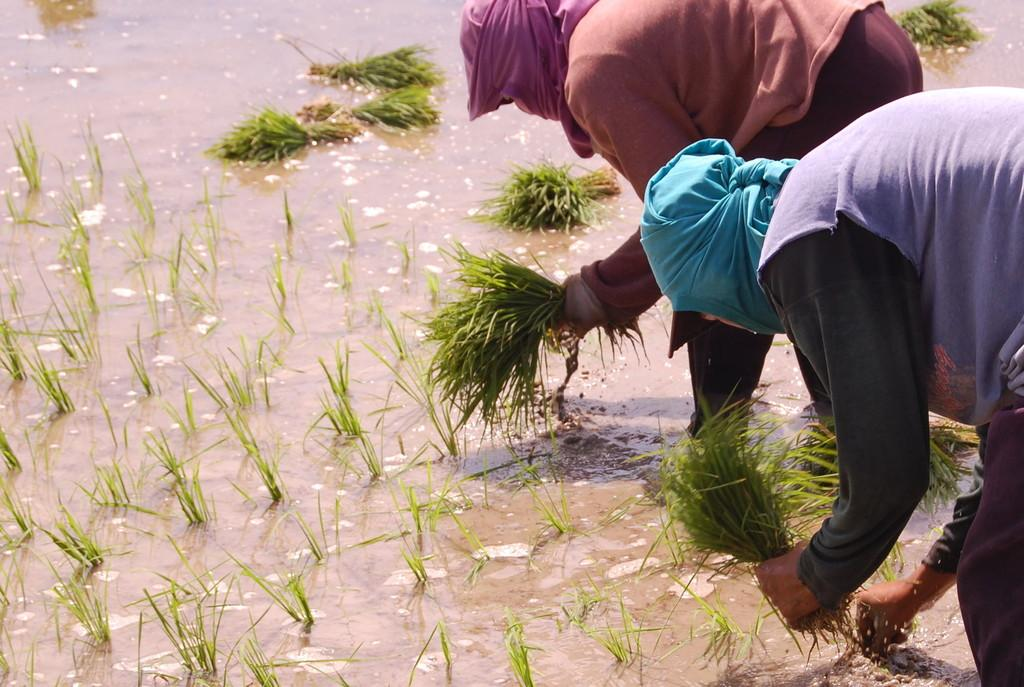How many people are in the image? There are two persons in the image. What are the persons doing in the image? The persons are bending and holding grass in their hands. What can be seen in the background of the image? There is water visible in the image. What type of vegetation is present in the image? There is grass in the image. Why do the persons have their faces covered with clothes? The reason for covering their faces with clothes is not mentioned in the facts. What type of bead is floating on the river in the image? There is no river or bead present in the image. What type of fruit can be seen hanging from the grass in the image? There is no fruit hanging from the grass in the image. 